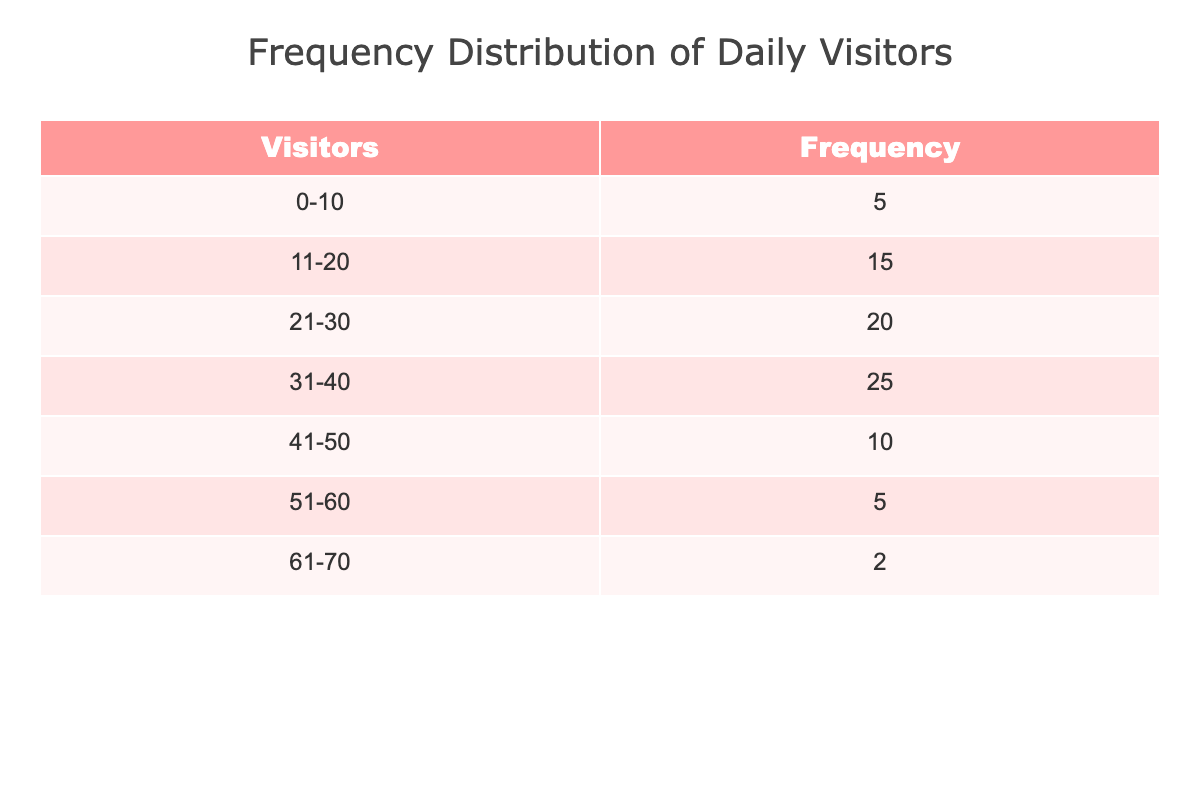What is the frequency of visitors in the range of 31-40? The table shows a frequency of visitors in that range as 25.
Answer: 25 How many total visitors fall in the range of 0-20? To find the total visitors in the range of 0-20, we need to sum the frequencies of 0-10 (5) and 11-20 (15). So, 5 + 15 = 20.
Answer: 20 Is it true that more visitors come in the range of 21-30 than the range of 41-50? Yes, the frequency for 21-30 is 20, whereas for 41-50, it is only 10. Therefore, it is true that more visitors come in the range of 21-30 than 41-50.
Answer: Yes What is the average number of visitors across all ranges? To calculate the average, first sum all the frequencies: 5 + 15 + 20 + 25 + 10 + 5 + 2 = 82. There are 7 groups, so the average is 82/7, which is approximately 11.71.
Answer: 11.71 How many total visitors are there for ranges above 30? We add the frequencies of 31-40 (25), 41-50 (10), 51-60 (5), and 61-70 (2): 25 + 10 + 5 + 2 = 42.
Answer: 42 What is the difference in frequency between the range with the highest visitors and the range with the lowest? The range with the highest visitors is 31-40 with a frequency of 25, and the lowest is 61-70 with a frequency of 2. The difference is 25 - 2 = 23.
Answer: 23 Is the sum of visitors in the range of 0-10 equal to the sum in the range of 51-60? The frequency for 0-10 is 5, and for 51-60, it is also 5. Since both sums are equal, the answer is yes.
Answer: Yes How many ranges have more than 15 visitors? The ranges with more than 15 visitors are 21-30 (20), 31-40 (25), and 41-50 (10). So there are 3 ranges that have more than 15 visitors.
Answer: 3 